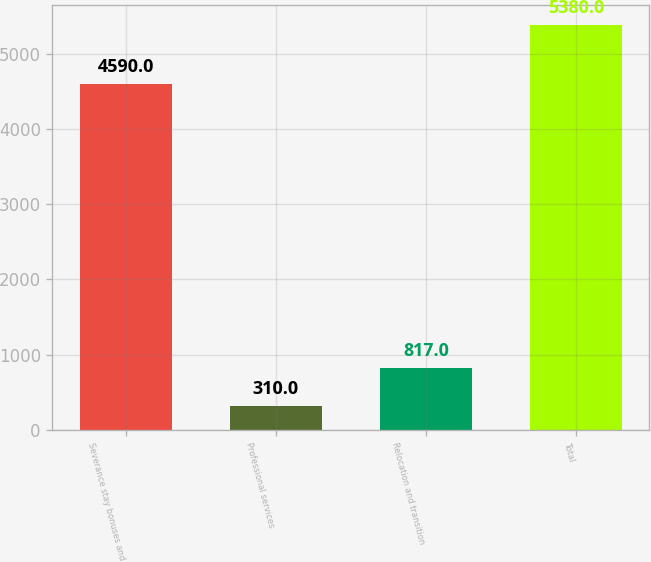Convert chart. <chart><loc_0><loc_0><loc_500><loc_500><bar_chart><fcel>Severance stay bonuses and<fcel>Professional services<fcel>Relocation and transition<fcel>Total<nl><fcel>4590<fcel>310<fcel>817<fcel>5380<nl></chart> 